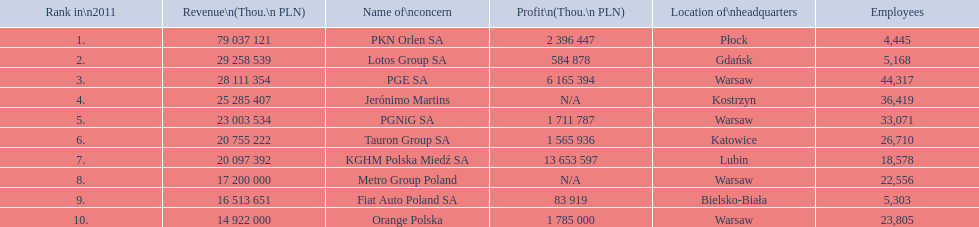Which concern's headquarters are located in warsaw? PGE SA, PGNiG SA, Metro Group Poland. Which of these listed a profit? PGE SA, PGNiG SA. Of these how many employees are in the concern with the lowest profit? 33,071. 